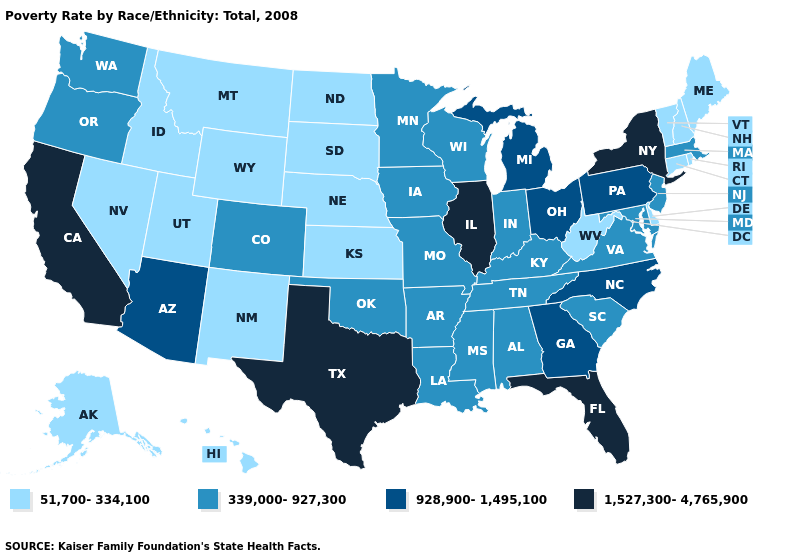Among the states that border Nevada , does California have the lowest value?
Keep it brief. No. Does New Hampshire have the highest value in the USA?
Give a very brief answer. No. What is the highest value in the USA?
Keep it brief. 1,527,300-4,765,900. Which states have the lowest value in the USA?
Answer briefly. Alaska, Connecticut, Delaware, Hawaii, Idaho, Kansas, Maine, Montana, Nebraska, Nevada, New Hampshire, New Mexico, North Dakota, Rhode Island, South Dakota, Utah, Vermont, West Virginia, Wyoming. What is the lowest value in the West?
Be succinct. 51,700-334,100. Name the states that have a value in the range 51,700-334,100?
Quick response, please. Alaska, Connecticut, Delaware, Hawaii, Idaho, Kansas, Maine, Montana, Nebraska, Nevada, New Hampshire, New Mexico, North Dakota, Rhode Island, South Dakota, Utah, Vermont, West Virginia, Wyoming. Does Massachusetts have the highest value in the Northeast?
Give a very brief answer. No. What is the value of South Dakota?
Write a very short answer. 51,700-334,100. Among the states that border Iowa , does Wisconsin have the highest value?
Be succinct. No. Which states have the highest value in the USA?
Be succinct. California, Florida, Illinois, New York, Texas. Name the states that have a value in the range 928,900-1,495,100?
Keep it brief. Arizona, Georgia, Michigan, North Carolina, Ohio, Pennsylvania. Does Rhode Island have the highest value in the Northeast?
Quick response, please. No. What is the lowest value in states that border Montana?
Quick response, please. 51,700-334,100. Name the states that have a value in the range 1,527,300-4,765,900?
Keep it brief. California, Florida, Illinois, New York, Texas. Name the states that have a value in the range 339,000-927,300?
Write a very short answer. Alabama, Arkansas, Colorado, Indiana, Iowa, Kentucky, Louisiana, Maryland, Massachusetts, Minnesota, Mississippi, Missouri, New Jersey, Oklahoma, Oregon, South Carolina, Tennessee, Virginia, Washington, Wisconsin. 